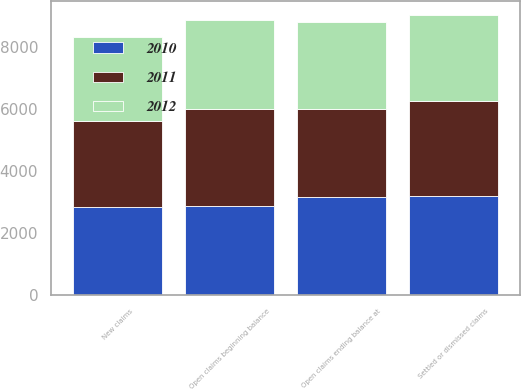Convert chart to OTSL. <chart><loc_0><loc_0><loc_500><loc_500><stacked_bar_chart><ecel><fcel>Open claims beginning balance<fcel>New claims<fcel>Settled or dismissed claims<fcel>Open claims ending balance at<nl><fcel>2012<fcel>2869<fcel>2719<fcel>2796<fcel>2792<nl><fcel>2011<fcel>3151<fcel>2781<fcel>3063<fcel>2869<nl><fcel>2010<fcel>2869<fcel>2843<fcel>3192<fcel>3151<nl></chart> 